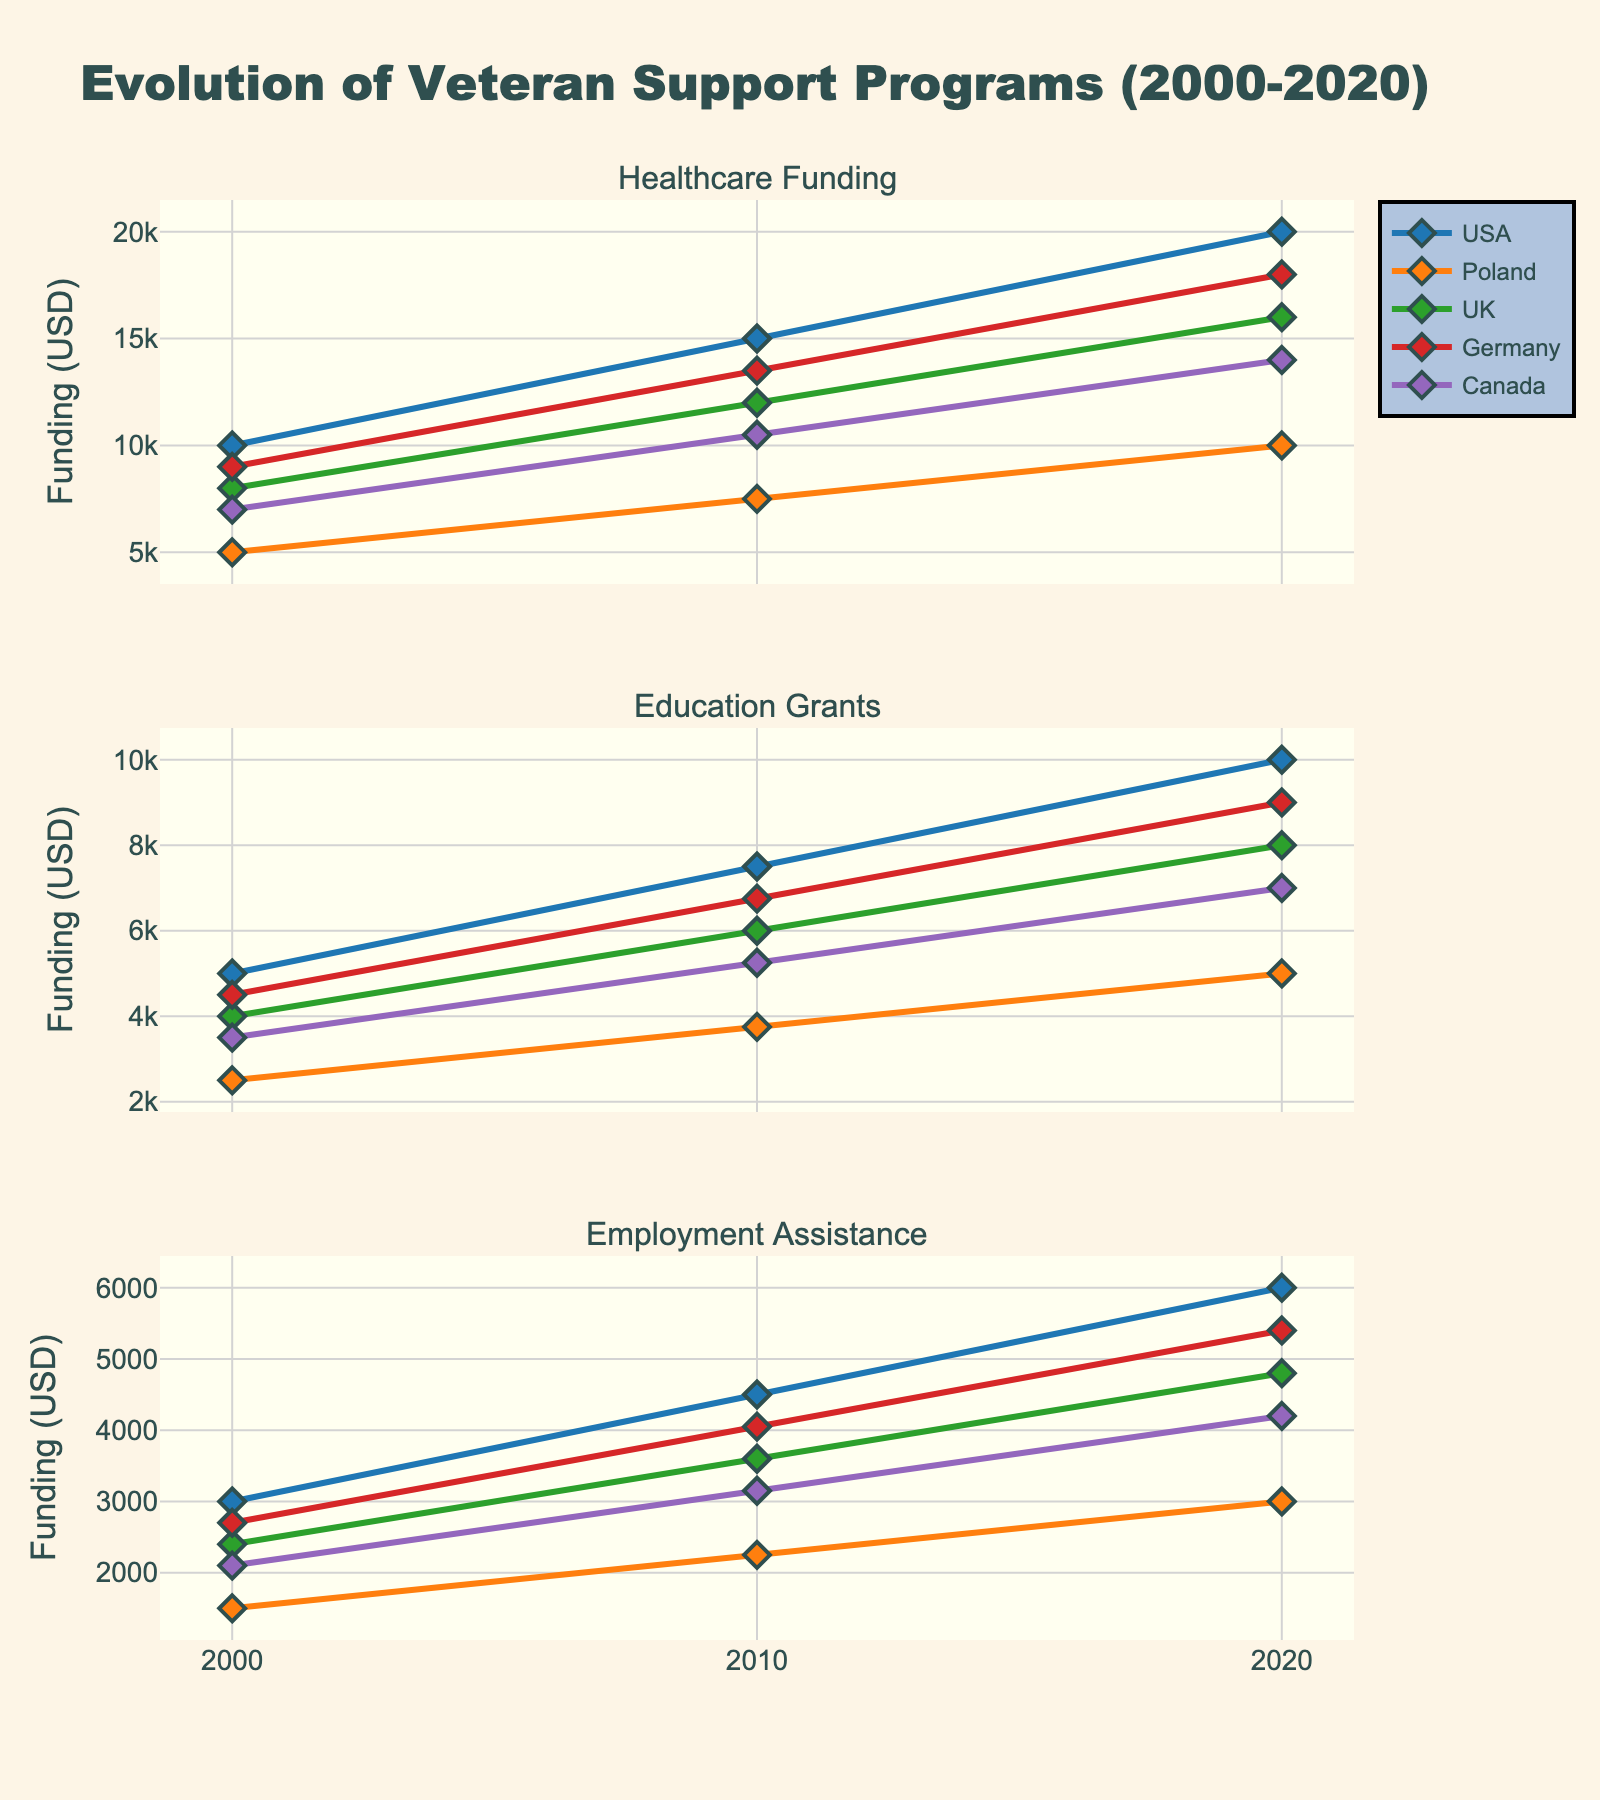Which country has the highest healthcare funding in 2020? We need to look at the healthcare funding line in the subplot titled "Healthcare Funding" and find the highest point for the year 2020. From the plot, Germany has the highest funding at $18,000.
Answer: Germany How much did Poland's education grants increase from 2000 to 2020? To find Poland's increase, we subtract the education grants in 2000 ($2,500) from the education grants in 2020 ($5,000). The increase is $5,000 - $2,500 = $2,500.
Answer: $2,500 Which two countries have the closest employment assistance funding in 2010? We need to compare the employment assistance funding values for all countries in 2010. The closest are Poland ($2,250) and Canada ($3,150). The difference is $3,150 - $2,250 = $900, which is the smallest among all pairs.
Answer: Poland and Canada What's the average healthcare funding for Canada across all years? We sum Canada's healthcare funding for 2000 ($7,000), 2010 ($10,500), and 2020 ($14,000), and divide by 3. The average is ($7,000 + $10,500 + $14,000) / 3 = $10,500.
Answer: $10,500 In which year did the UK's employment assistance funding see the highest increase? We compare the increases between the years for the UK: from 2000 to 2010 ($3,600 - $2,400 = $1,200) and from 2010 to 2020 ($4,800 - $3,600 = $1,200). Both intervals have the same increase of $1,200.
Answer: 2000 to 2010 and 2010 to 2020 Did the USA or Germany have a greater increase in healthcare funding from 2000 to 2020? We find the increase for both countries: USA from $10,000 to $20,000 ($10,000) and Germany from $9,000 to $18,000 ($9,000). The USA has a greater increase.
Answer: USA What's the percentage increase in employment assistance for the UK from 2000 to 2020? We calculate the percentage increase from $2,400 in 2000 to $4,800 in 2020. The increase is ($4,800 - $2,400) / $2,400 * 100% = 100%.
Answer: 100% Which metric had the highest total funding across all countries in 2020? We sum the 2020 funding for each metric across all countries: Healthcare ($20,000 + $10,000 + $16,000 + $18,000 + $14,000 = $78,000), Education ($10,000 + $5,000 + $8,000 + $9,000 + $7,000 = $39,000), and Employment ($6,000 + $3,000 + $4,800 + $5,400 + $4,200 = $23,400). Healthcare had the highest total.
Answer: Healthcare 